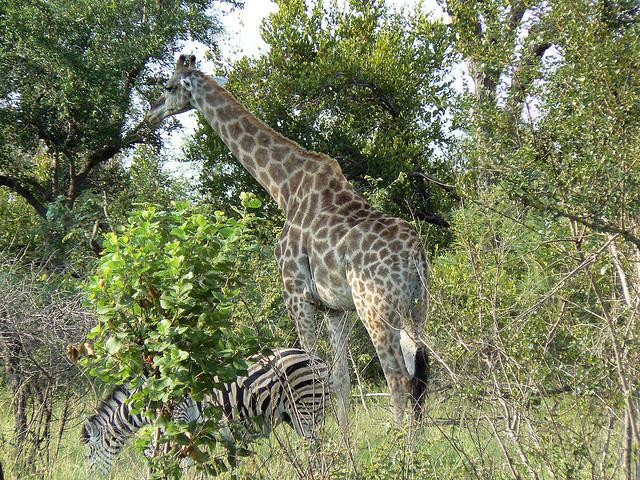Is this a forest?
Be succinct. Yes. What color is the zebra?
Quick response, please. Black and white. Where are they?
Write a very short answer. In wild. Is this a sunny day?
Be succinct. Yes. What is the tallest animal?
Be succinct. Giraffe. What animal is depicted?
Keep it brief. Giraffe. How many zebra are walking through the field?
Give a very brief answer. 1. 